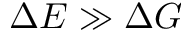Convert formula to latex. <formula><loc_0><loc_0><loc_500><loc_500>\Delta E \gg \Delta G</formula> 